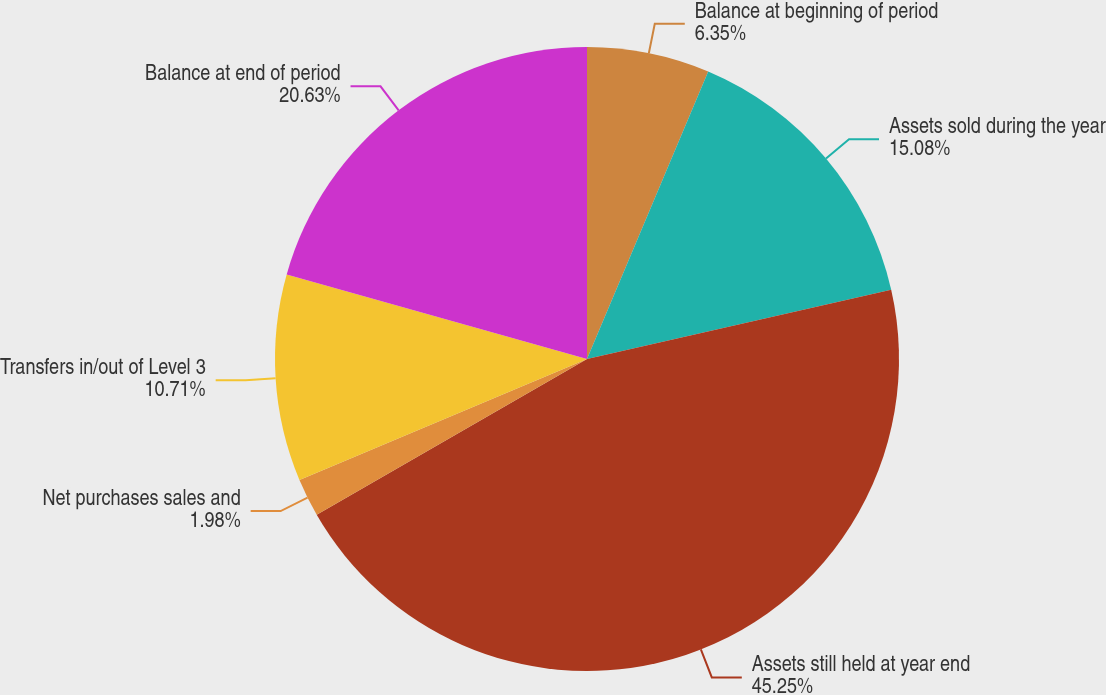<chart> <loc_0><loc_0><loc_500><loc_500><pie_chart><fcel>Balance at beginning of period<fcel>Assets sold during the year<fcel>Assets still held at year end<fcel>Net purchases sales and<fcel>Transfers in/out of Level 3<fcel>Balance at end of period<nl><fcel>6.35%<fcel>15.08%<fcel>45.24%<fcel>1.98%<fcel>10.71%<fcel>20.63%<nl></chart> 